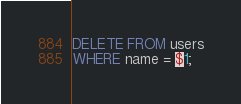<code> <loc_0><loc_0><loc_500><loc_500><_SQL_>DELETE FROM users
WHERE name = $1;

</code> 